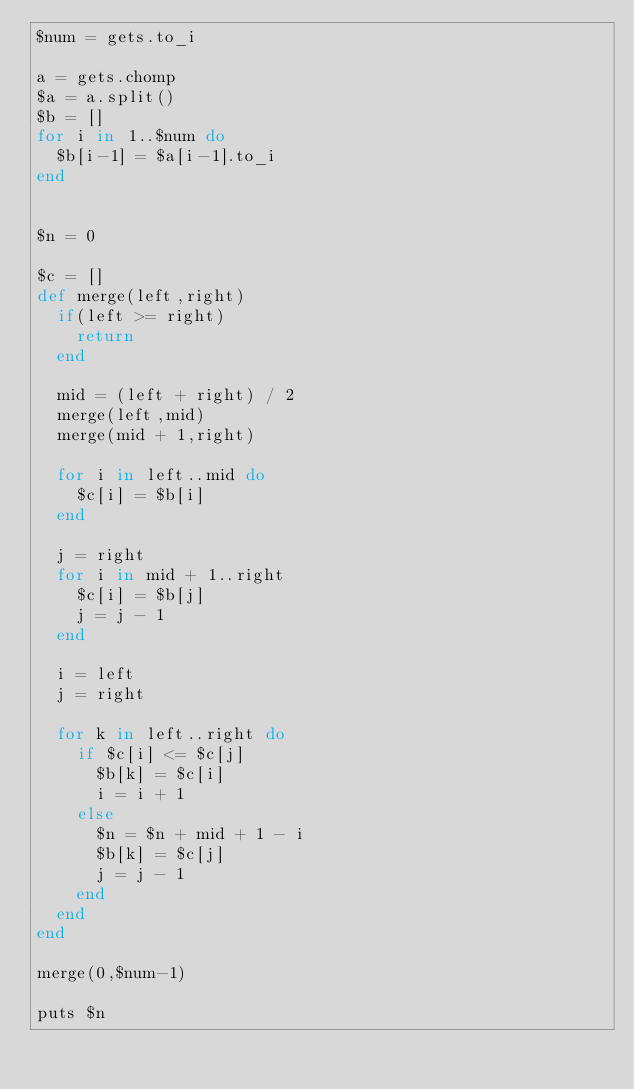Convert code to text. <code><loc_0><loc_0><loc_500><loc_500><_Ruby_>$num = gets.to_i

a = gets.chomp
$a = a.split()
$b = []
for i in 1..$num do
	$b[i-1] = $a[i-1].to_i
end


$n = 0

$c = []
def merge(left,right)
	if(left >= right)
		return
	end

	mid = (left + right) / 2
	merge(left,mid)
	merge(mid + 1,right)
	
	for i in left..mid do
		$c[i] = $b[i]
	end

	j = right
	for i in mid + 1..right
		$c[i] = $b[j]
		j = j - 1
	end

	i = left
	j = right 

	for k in left..right do
		if $c[i] <= $c[j]
			$b[k] = $c[i]
			i = i + 1
		else
			$n = $n + mid + 1 - i
			$b[k] = $c[j]
			j = j - 1
		end
	end
end

merge(0,$num-1)

puts $n</code> 